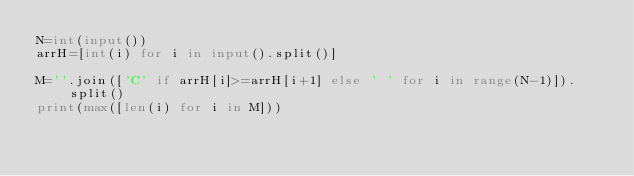<code> <loc_0><loc_0><loc_500><loc_500><_Python_>N=int(input())
arrH=[int(i) for i in input().split()]

M=''.join(['C' if arrH[i]>=arrH[i+1] else ' ' for i in range(N-1)]).split()
print(max([len(i) for i in M]))
</code> 